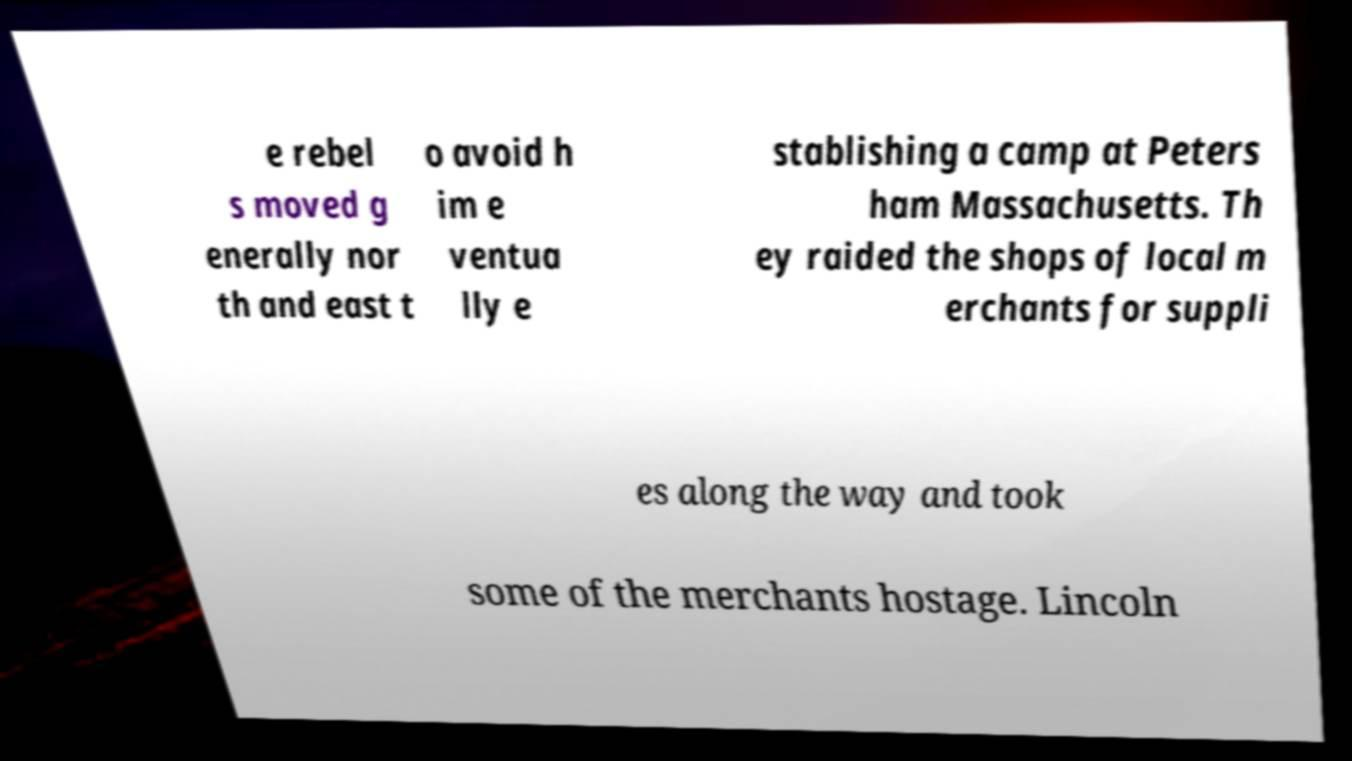Could you assist in decoding the text presented in this image and type it out clearly? e rebel s moved g enerally nor th and east t o avoid h im e ventua lly e stablishing a camp at Peters ham Massachusetts. Th ey raided the shops of local m erchants for suppli es along the way and took some of the merchants hostage. Lincoln 